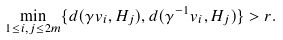Convert formula to latex. <formula><loc_0><loc_0><loc_500><loc_500>\min _ { 1 \leq i , j \leq 2 m } \{ d ( \gamma v _ { i } , H _ { j } ) , d ( \gamma ^ { - 1 } v _ { i } , H _ { j } ) \} > r .</formula> 